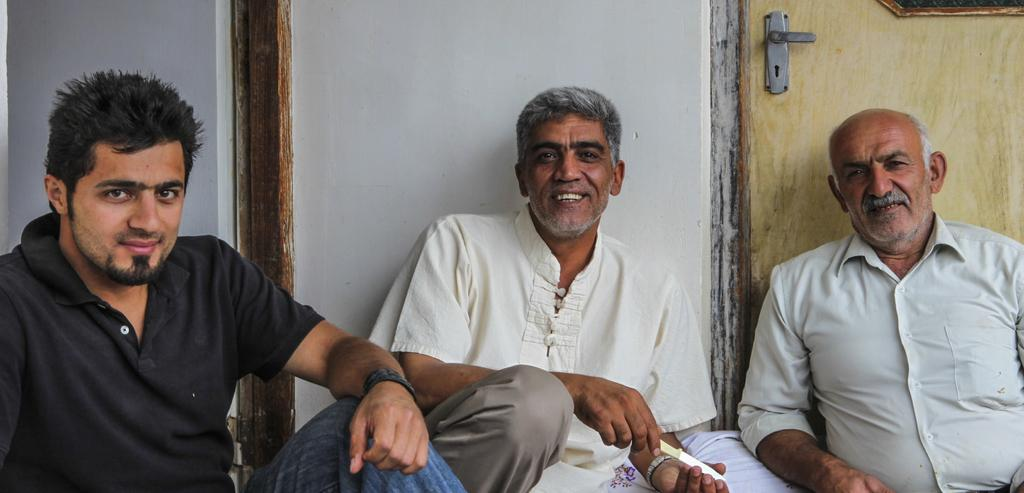How many people are sitting in the image? There are three persons sitting in the image. What is the facial expression of the persons? The persons are smiling. What is one person holding in the image? One person is holding a knife. What is located behind the persons? There is a wall behind the persons. What architectural feature can be seen in the image? There is a door visible in the image. What type of stamp can be seen on the door in the image? There is no stamp visible on the door in the image. 